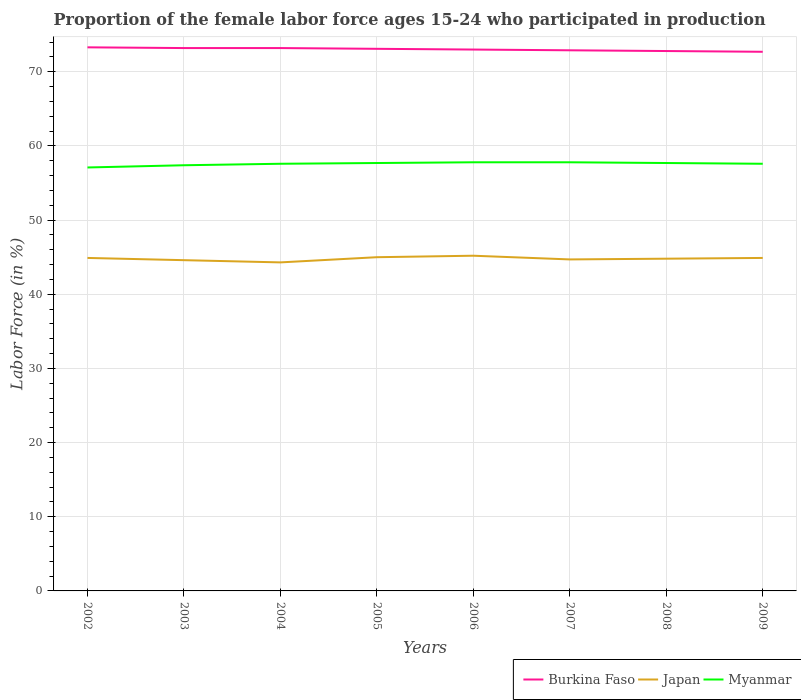How many different coloured lines are there?
Keep it short and to the point. 3. Across all years, what is the maximum proportion of the female labor force who participated in production in Myanmar?
Your response must be concise. 57.1. In which year was the proportion of the female labor force who participated in production in Japan maximum?
Give a very brief answer. 2004. What is the total proportion of the female labor force who participated in production in Japan in the graph?
Offer a terse response. -0.2. What is the difference between the highest and the second highest proportion of the female labor force who participated in production in Burkina Faso?
Offer a terse response. 0.6. What is the difference between the highest and the lowest proportion of the female labor force who participated in production in Burkina Faso?
Your response must be concise. 4. How many lines are there?
Offer a very short reply. 3. What is the difference between two consecutive major ticks on the Y-axis?
Make the answer very short. 10. Does the graph contain any zero values?
Offer a terse response. No. What is the title of the graph?
Your answer should be compact. Proportion of the female labor force ages 15-24 who participated in production. Does "Burkina Faso" appear as one of the legend labels in the graph?
Keep it short and to the point. Yes. What is the label or title of the Y-axis?
Your answer should be very brief. Labor Force (in %). What is the Labor Force (in %) of Burkina Faso in 2002?
Your answer should be very brief. 73.3. What is the Labor Force (in %) of Japan in 2002?
Your answer should be very brief. 44.9. What is the Labor Force (in %) of Myanmar in 2002?
Your answer should be very brief. 57.1. What is the Labor Force (in %) in Burkina Faso in 2003?
Keep it short and to the point. 73.2. What is the Labor Force (in %) in Japan in 2003?
Offer a very short reply. 44.6. What is the Labor Force (in %) in Myanmar in 2003?
Offer a very short reply. 57.4. What is the Labor Force (in %) of Burkina Faso in 2004?
Ensure brevity in your answer.  73.2. What is the Labor Force (in %) in Japan in 2004?
Provide a short and direct response. 44.3. What is the Labor Force (in %) of Myanmar in 2004?
Your answer should be compact. 57.6. What is the Labor Force (in %) in Burkina Faso in 2005?
Your response must be concise. 73.1. What is the Labor Force (in %) of Japan in 2005?
Keep it short and to the point. 45. What is the Labor Force (in %) of Myanmar in 2005?
Provide a short and direct response. 57.7. What is the Labor Force (in %) of Burkina Faso in 2006?
Provide a succinct answer. 73. What is the Labor Force (in %) of Japan in 2006?
Provide a succinct answer. 45.2. What is the Labor Force (in %) in Myanmar in 2006?
Provide a succinct answer. 57.8. What is the Labor Force (in %) in Burkina Faso in 2007?
Keep it short and to the point. 72.9. What is the Labor Force (in %) of Japan in 2007?
Your response must be concise. 44.7. What is the Labor Force (in %) in Myanmar in 2007?
Your response must be concise. 57.8. What is the Labor Force (in %) in Burkina Faso in 2008?
Your response must be concise. 72.8. What is the Labor Force (in %) of Japan in 2008?
Provide a succinct answer. 44.8. What is the Labor Force (in %) in Myanmar in 2008?
Give a very brief answer. 57.7. What is the Labor Force (in %) of Burkina Faso in 2009?
Your response must be concise. 72.7. What is the Labor Force (in %) of Japan in 2009?
Give a very brief answer. 44.9. What is the Labor Force (in %) of Myanmar in 2009?
Your answer should be compact. 57.6. Across all years, what is the maximum Labor Force (in %) of Burkina Faso?
Your response must be concise. 73.3. Across all years, what is the maximum Labor Force (in %) in Japan?
Your answer should be compact. 45.2. Across all years, what is the maximum Labor Force (in %) in Myanmar?
Your answer should be very brief. 57.8. Across all years, what is the minimum Labor Force (in %) in Burkina Faso?
Your answer should be very brief. 72.7. Across all years, what is the minimum Labor Force (in %) of Japan?
Your answer should be very brief. 44.3. Across all years, what is the minimum Labor Force (in %) of Myanmar?
Your answer should be compact. 57.1. What is the total Labor Force (in %) in Burkina Faso in the graph?
Provide a succinct answer. 584.2. What is the total Labor Force (in %) in Japan in the graph?
Keep it short and to the point. 358.4. What is the total Labor Force (in %) in Myanmar in the graph?
Make the answer very short. 460.7. What is the difference between the Labor Force (in %) of Burkina Faso in 2002 and that in 2003?
Ensure brevity in your answer.  0.1. What is the difference between the Labor Force (in %) of Burkina Faso in 2002 and that in 2004?
Your answer should be very brief. 0.1. What is the difference between the Labor Force (in %) in Japan in 2002 and that in 2005?
Give a very brief answer. -0.1. What is the difference between the Labor Force (in %) of Myanmar in 2002 and that in 2005?
Keep it short and to the point. -0.6. What is the difference between the Labor Force (in %) in Burkina Faso in 2002 and that in 2006?
Your answer should be very brief. 0.3. What is the difference between the Labor Force (in %) of Japan in 2002 and that in 2007?
Give a very brief answer. 0.2. What is the difference between the Labor Force (in %) in Myanmar in 2002 and that in 2007?
Offer a terse response. -0.7. What is the difference between the Labor Force (in %) of Burkina Faso in 2002 and that in 2008?
Offer a terse response. 0.5. What is the difference between the Labor Force (in %) in Myanmar in 2002 and that in 2009?
Give a very brief answer. -0.5. What is the difference between the Labor Force (in %) of Burkina Faso in 2003 and that in 2004?
Your response must be concise. 0. What is the difference between the Labor Force (in %) of Japan in 2003 and that in 2004?
Provide a succinct answer. 0.3. What is the difference between the Labor Force (in %) of Myanmar in 2003 and that in 2004?
Give a very brief answer. -0.2. What is the difference between the Labor Force (in %) of Burkina Faso in 2003 and that in 2005?
Your answer should be very brief. 0.1. What is the difference between the Labor Force (in %) of Japan in 2003 and that in 2005?
Make the answer very short. -0.4. What is the difference between the Labor Force (in %) in Myanmar in 2003 and that in 2005?
Ensure brevity in your answer.  -0.3. What is the difference between the Labor Force (in %) of Japan in 2003 and that in 2007?
Ensure brevity in your answer.  -0.1. What is the difference between the Labor Force (in %) of Myanmar in 2003 and that in 2009?
Make the answer very short. -0.2. What is the difference between the Labor Force (in %) in Japan in 2004 and that in 2005?
Your answer should be compact. -0.7. What is the difference between the Labor Force (in %) of Myanmar in 2004 and that in 2005?
Your response must be concise. -0.1. What is the difference between the Labor Force (in %) in Myanmar in 2004 and that in 2006?
Offer a very short reply. -0.2. What is the difference between the Labor Force (in %) in Burkina Faso in 2004 and that in 2008?
Ensure brevity in your answer.  0.4. What is the difference between the Labor Force (in %) in Japan in 2004 and that in 2008?
Provide a succinct answer. -0.5. What is the difference between the Labor Force (in %) of Myanmar in 2004 and that in 2008?
Ensure brevity in your answer.  -0.1. What is the difference between the Labor Force (in %) in Burkina Faso in 2004 and that in 2009?
Your answer should be compact. 0.5. What is the difference between the Labor Force (in %) of Japan in 2005 and that in 2006?
Your answer should be compact. -0.2. What is the difference between the Labor Force (in %) in Burkina Faso in 2005 and that in 2007?
Offer a terse response. 0.2. What is the difference between the Labor Force (in %) of Burkina Faso in 2005 and that in 2008?
Give a very brief answer. 0.3. What is the difference between the Labor Force (in %) in Japan in 2005 and that in 2008?
Provide a succinct answer. 0.2. What is the difference between the Labor Force (in %) in Japan in 2005 and that in 2009?
Your response must be concise. 0.1. What is the difference between the Labor Force (in %) in Burkina Faso in 2006 and that in 2007?
Your answer should be compact. 0.1. What is the difference between the Labor Force (in %) in Japan in 2006 and that in 2007?
Give a very brief answer. 0.5. What is the difference between the Labor Force (in %) of Myanmar in 2006 and that in 2007?
Make the answer very short. 0. What is the difference between the Labor Force (in %) of Burkina Faso in 2006 and that in 2008?
Ensure brevity in your answer.  0.2. What is the difference between the Labor Force (in %) of Japan in 2006 and that in 2008?
Your answer should be very brief. 0.4. What is the difference between the Labor Force (in %) in Myanmar in 2006 and that in 2009?
Your answer should be compact. 0.2. What is the difference between the Labor Force (in %) in Japan in 2007 and that in 2008?
Ensure brevity in your answer.  -0.1. What is the difference between the Labor Force (in %) of Myanmar in 2007 and that in 2008?
Offer a terse response. 0.1. What is the difference between the Labor Force (in %) of Japan in 2007 and that in 2009?
Ensure brevity in your answer.  -0.2. What is the difference between the Labor Force (in %) of Myanmar in 2007 and that in 2009?
Offer a terse response. 0.2. What is the difference between the Labor Force (in %) in Japan in 2008 and that in 2009?
Keep it short and to the point. -0.1. What is the difference between the Labor Force (in %) of Burkina Faso in 2002 and the Labor Force (in %) of Japan in 2003?
Offer a very short reply. 28.7. What is the difference between the Labor Force (in %) in Burkina Faso in 2002 and the Labor Force (in %) in Myanmar in 2003?
Provide a succinct answer. 15.9. What is the difference between the Labor Force (in %) in Burkina Faso in 2002 and the Labor Force (in %) in Japan in 2004?
Provide a succinct answer. 29. What is the difference between the Labor Force (in %) of Burkina Faso in 2002 and the Labor Force (in %) of Japan in 2005?
Provide a short and direct response. 28.3. What is the difference between the Labor Force (in %) of Japan in 2002 and the Labor Force (in %) of Myanmar in 2005?
Your answer should be compact. -12.8. What is the difference between the Labor Force (in %) of Burkina Faso in 2002 and the Labor Force (in %) of Japan in 2006?
Your answer should be very brief. 28.1. What is the difference between the Labor Force (in %) in Burkina Faso in 2002 and the Labor Force (in %) in Myanmar in 2006?
Your response must be concise. 15.5. What is the difference between the Labor Force (in %) of Japan in 2002 and the Labor Force (in %) of Myanmar in 2006?
Provide a succinct answer. -12.9. What is the difference between the Labor Force (in %) of Burkina Faso in 2002 and the Labor Force (in %) of Japan in 2007?
Offer a terse response. 28.6. What is the difference between the Labor Force (in %) of Burkina Faso in 2002 and the Labor Force (in %) of Myanmar in 2007?
Give a very brief answer. 15.5. What is the difference between the Labor Force (in %) of Japan in 2002 and the Labor Force (in %) of Myanmar in 2007?
Make the answer very short. -12.9. What is the difference between the Labor Force (in %) of Burkina Faso in 2002 and the Labor Force (in %) of Japan in 2008?
Ensure brevity in your answer.  28.5. What is the difference between the Labor Force (in %) of Burkina Faso in 2002 and the Labor Force (in %) of Myanmar in 2008?
Your response must be concise. 15.6. What is the difference between the Labor Force (in %) of Japan in 2002 and the Labor Force (in %) of Myanmar in 2008?
Your answer should be very brief. -12.8. What is the difference between the Labor Force (in %) of Burkina Faso in 2002 and the Labor Force (in %) of Japan in 2009?
Keep it short and to the point. 28.4. What is the difference between the Labor Force (in %) in Burkina Faso in 2002 and the Labor Force (in %) in Myanmar in 2009?
Provide a succinct answer. 15.7. What is the difference between the Labor Force (in %) in Japan in 2002 and the Labor Force (in %) in Myanmar in 2009?
Provide a succinct answer. -12.7. What is the difference between the Labor Force (in %) in Burkina Faso in 2003 and the Labor Force (in %) in Japan in 2004?
Your answer should be very brief. 28.9. What is the difference between the Labor Force (in %) of Burkina Faso in 2003 and the Labor Force (in %) of Japan in 2005?
Offer a terse response. 28.2. What is the difference between the Labor Force (in %) of Japan in 2003 and the Labor Force (in %) of Myanmar in 2005?
Give a very brief answer. -13.1. What is the difference between the Labor Force (in %) of Burkina Faso in 2003 and the Labor Force (in %) of Japan in 2006?
Make the answer very short. 28. What is the difference between the Labor Force (in %) of Burkina Faso in 2003 and the Labor Force (in %) of Japan in 2008?
Offer a very short reply. 28.4. What is the difference between the Labor Force (in %) of Burkina Faso in 2003 and the Labor Force (in %) of Myanmar in 2008?
Your answer should be very brief. 15.5. What is the difference between the Labor Force (in %) of Japan in 2003 and the Labor Force (in %) of Myanmar in 2008?
Your answer should be compact. -13.1. What is the difference between the Labor Force (in %) in Burkina Faso in 2003 and the Labor Force (in %) in Japan in 2009?
Your answer should be compact. 28.3. What is the difference between the Labor Force (in %) in Burkina Faso in 2003 and the Labor Force (in %) in Myanmar in 2009?
Ensure brevity in your answer.  15.6. What is the difference between the Labor Force (in %) of Burkina Faso in 2004 and the Labor Force (in %) of Japan in 2005?
Your answer should be very brief. 28.2. What is the difference between the Labor Force (in %) in Burkina Faso in 2004 and the Labor Force (in %) in Myanmar in 2005?
Your response must be concise. 15.5. What is the difference between the Labor Force (in %) in Japan in 2004 and the Labor Force (in %) in Myanmar in 2005?
Provide a succinct answer. -13.4. What is the difference between the Labor Force (in %) in Burkina Faso in 2004 and the Labor Force (in %) in Myanmar in 2007?
Provide a short and direct response. 15.4. What is the difference between the Labor Force (in %) of Burkina Faso in 2004 and the Labor Force (in %) of Japan in 2008?
Offer a terse response. 28.4. What is the difference between the Labor Force (in %) of Burkina Faso in 2004 and the Labor Force (in %) of Myanmar in 2008?
Your answer should be very brief. 15.5. What is the difference between the Labor Force (in %) in Japan in 2004 and the Labor Force (in %) in Myanmar in 2008?
Offer a terse response. -13.4. What is the difference between the Labor Force (in %) of Burkina Faso in 2004 and the Labor Force (in %) of Japan in 2009?
Your answer should be compact. 28.3. What is the difference between the Labor Force (in %) of Japan in 2004 and the Labor Force (in %) of Myanmar in 2009?
Provide a short and direct response. -13.3. What is the difference between the Labor Force (in %) in Burkina Faso in 2005 and the Labor Force (in %) in Japan in 2006?
Offer a very short reply. 27.9. What is the difference between the Labor Force (in %) in Burkina Faso in 2005 and the Labor Force (in %) in Japan in 2007?
Your answer should be compact. 28.4. What is the difference between the Labor Force (in %) in Burkina Faso in 2005 and the Labor Force (in %) in Japan in 2008?
Give a very brief answer. 28.3. What is the difference between the Labor Force (in %) of Burkina Faso in 2005 and the Labor Force (in %) of Myanmar in 2008?
Provide a succinct answer. 15.4. What is the difference between the Labor Force (in %) of Japan in 2005 and the Labor Force (in %) of Myanmar in 2008?
Your answer should be very brief. -12.7. What is the difference between the Labor Force (in %) in Burkina Faso in 2005 and the Labor Force (in %) in Japan in 2009?
Keep it short and to the point. 28.2. What is the difference between the Labor Force (in %) of Burkina Faso in 2005 and the Labor Force (in %) of Myanmar in 2009?
Ensure brevity in your answer.  15.5. What is the difference between the Labor Force (in %) in Japan in 2005 and the Labor Force (in %) in Myanmar in 2009?
Your response must be concise. -12.6. What is the difference between the Labor Force (in %) of Burkina Faso in 2006 and the Labor Force (in %) of Japan in 2007?
Your answer should be very brief. 28.3. What is the difference between the Labor Force (in %) of Burkina Faso in 2006 and the Labor Force (in %) of Myanmar in 2007?
Your answer should be very brief. 15.2. What is the difference between the Labor Force (in %) in Japan in 2006 and the Labor Force (in %) in Myanmar in 2007?
Provide a succinct answer. -12.6. What is the difference between the Labor Force (in %) in Burkina Faso in 2006 and the Labor Force (in %) in Japan in 2008?
Provide a succinct answer. 28.2. What is the difference between the Labor Force (in %) in Burkina Faso in 2006 and the Labor Force (in %) in Japan in 2009?
Your answer should be very brief. 28.1. What is the difference between the Labor Force (in %) in Burkina Faso in 2006 and the Labor Force (in %) in Myanmar in 2009?
Ensure brevity in your answer.  15.4. What is the difference between the Labor Force (in %) of Burkina Faso in 2007 and the Labor Force (in %) of Japan in 2008?
Make the answer very short. 28.1. What is the difference between the Labor Force (in %) in Burkina Faso in 2007 and the Labor Force (in %) in Japan in 2009?
Your response must be concise. 28. What is the difference between the Labor Force (in %) in Japan in 2007 and the Labor Force (in %) in Myanmar in 2009?
Give a very brief answer. -12.9. What is the difference between the Labor Force (in %) in Burkina Faso in 2008 and the Labor Force (in %) in Japan in 2009?
Offer a terse response. 27.9. What is the difference between the Labor Force (in %) of Burkina Faso in 2008 and the Labor Force (in %) of Myanmar in 2009?
Keep it short and to the point. 15.2. What is the difference between the Labor Force (in %) of Japan in 2008 and the Labor Force (in %) of Myanmar in 2009?
Ensure brevity in your answer.  -12.8. What is the average Labor Force (in %) of Burkina Faso per year?
Your answer should be compact. 73.03. What is the average Labor Force (in %) in Japan per year?
Make the answer very short. 44.8. What is the average Labor Force (in %) in Myanmar per year?
Give a very brief answer. 57.59. In the year 2002, what is the difference between the Labor Force (in %) of Burkina Faso and Labor Force (in %) of Japan?
Provide a short and direct response. 28.4. In the year 2003, what is the difference between the Labor Force (in %) in Burkina Faso and Labor Force (in %) in Japan?
Your answer should be very brief. 28.6. In the year 2003, what is the difference between the Labor Force (in %) in Burkina Faso and Labor Force (in %) in Myanmar?
Give a very brief answer. 15.8. In the year 2003, what is the difference between the Labor Force (in %) in Japan and Labor Force (in %) in Myanmar?
Your response must be concise. -12.8. In the year 2004, what is the difference between the Labor Force (in %) in Burkina Faso and Labor Force (in %) in Japan?
Provide a short and direct response. 28.9. In the year 2005, what is the difference between the Labor Force (in %) of Burkina Faso and Labor Force (in %) of Japan?
Make the answer very short. 28.1. In the year 2006, what is the difference between the Labor Force (in %) in Burkina Faso and Labor Force (in %) in Japan?
Provide a short and direct response. 27.8. In the year 2006, what is the difference between the Labor Force (in %) in Burkina Faso and Labor Force (in %) in Myanmar?
Make the answer very short. 15.2. In the year 2006, what is the difference between the Labor Force (in %) in Japan and Labor Force (in %) in Myanmar?
Provide a succinct answer. -12.6. In the year 2007, what is the difference between the Labor Force (in %) of Burkina Faso and Labor Force (in %) of Japan?
Provide a short and direct response. 28.2. In the year 2007, what is the difference between the Labor Force (in %) in Japan and Labor Force (in %) in Myanmar?
Provide a succinct answer. -13.1. In the year 2008, what is the difference between the Labor Force (in %) in Burkina Faso and Labor Force (in %) in Japan?
Offer a very short reply. 28. In the year 2008, what is the difference between the Labor Force (in %) of Japan and Labor Force (in %) of Myanmar?
Your response must be concise. -12.9. In the year 2009, what is the difference between the Labor Force (in %) in Burkina Faso and Labor Force (in %) in Japan?
Provide a succinct answer. 27.8. What is the ratio of the Labor Force (in %) of Burkina Faso in 2002 to that in 2003?
Offer a very short reply. 1. What is the ratio of the Labor Force (in %) of Japan in 2002 to that in 2003?
Give a very brief answer. 1.01. What is the ratio of the Labor Force (in %) in Myanmar in 2002 to that in 2003?
Keep it short and to the point. 0.99. What is the ratio of the Labor Force (in %) in Burkina Faso in 2002 to that in 2004?
Your answer should be compact. 1. What is the ratio of the Labor Force (in %) of Japan in 2002 to that in 2004?
Make the answer very short. 1.01. What is the ratio of the Labor Force (in %) in Japan in 2002 to that in 2005?
Your answer should be very brief. 1. What is the ratio of the Labor Force (in %) of Burkina Faso in 2002 to that in 2006?
Offer a terse response. 1. What is the ratio of the Labor Force (in %) in Myanmar in 2002 to that in 2006?
Your answer should be very brief. 0.99. What is the ratio of the Labor Force (in %) in Myanmar in 2002 to that in 2007?
Your answer should be compact. 0.99. What is the ratio of the Labor Force (in %) in Burkina Faso in 2002 to that in 2008?
Your answer should be compact. 1.01. What is the ratio of the Labor Force (in %) of Burkina Faso in 2002 to that in 2009?
Offer a very short reply. 1.01. What is the ratio of the Labor Force (in %) of Japan in 2003 to that in 2004?
Your answer should be very brief. 1.01. What is the ratio of the Labor Force (in %) of Myanmar in 2003 to that in 2004?
Your answer should be very brief. 1. What is the ratio of the Labor Force (in %) of Japan in 2003 to that in 2005?
Your response must be concise. 0.99. What is the ratio of the Labor Force (in %) of Japan in 2003 to that in 2006?
Ensure brevity in your answer.  0.99. What is the ratio of the Labor Force (in %) in Myanmar in 2003 to that in 2006?
Keep it short and to the point. 0.99. What is the ratio of the Labor Force (in %) in Japan in 2003 to that in 2007?
Make the answer very short. 1. What is the ratio of the Labor Force (in %) of Myanmar in 2003 to that in 2007?
Your answer should be very brief. 0.99. What is the ratio of the Labor Force (in %) in Burkina Faso in 2003 to that in 2008?
Your answer should be compact. 1.01. What is the ratio of the Labor Force (in %) in Myanmar in 2003 to that in 2009?
Your answer should be very brief. 1. What is the ratio of the Labor Force (in %) of Burkina Faso in 2004 to that in 2005?
Provide a short and direct response. 1. What is the ratio of the Labor Force (in %) of Japan in 2004 to that in 2005?
Your response must be concise. 0.98. What is the ratio of the Labor Force (in %) in Japan in 2004 to that in 2006?
Make the answer very short. 0.98. What is the ratio of the Labor Force (in %) in Myanmar in 2004 to that in 2006?
Give a very brief answer. 1. What is the ratio of the Labor Force (in %) of Burkina Faso in 2004 to that in 2007?
Your answer should be compact. 1. What is the ratio of the Labor Force (in %) of Myanmar in 2004 to that in 2007?
Ensure brevity in your answer.  1. What is the ratio of the Labor Force (in %) of Japan in 2004 to that in 2008?
Ensure brevity in your answer.  0.99. What is the ratio of the Labor Force (in %) in Burkina Faso in 2004 to that in 2009?
Provide a succinct answer. 1.01. What is the ratio of the Labor Force (in %) of Japan in 2004 to that in 2009?
Provide a succinct answer. 0.99. What is the ratio of the Labor Force (in %) of Myanmar in 2004 to that in 2009?
Provide a short and direct response. 1. What is the ratio of the Labor Force (in %) in Myanmar in 2005 to that in 2006?
Give a very brief answer. 1. What is the ratio of the Labor Force (in %) in Myanmar in 2005 to that in 2007?
Your response must be concise. 1. What is the ratio of the Labor Force (in %) of Burkina Faso in 2005 to that in 2008?
Provide a short and direct response. 1. What is the ratio of the Labor Force (in %) in Myanmar in 2005 to that in 2008?
Give a very brief answer. 1. What is the ratio of the Labor Force (in %) in Burkina Faso in 2005 to that in 2009?
Ensure brevity in your answer.  1.01. What is the ratio of the Labor Force (in %) in Japan in 2005 to that in 2009?
Your answer should be very brief. 1. What is the ratio of the Labor Force (in %) in Burkina Faso in 2006 to that in 2007?
Keep it short and to the point. 1. What is the ratio of the Labor Force (in %) in Japan in 2006 to that in 2007?
Your answer should be very brief. 1.01. What is the ratio of the Labor Force (in %) of Japan in 2006 to that in 2008?
Offer a very short reply. 1.01. What is the ratio of the Labor Force (in %) in Myanmar in 2006 to that in 2008?
Provide a short and direct response. 1. What is the ratio of the Labor Force (in %) of Burkina Faso in 2006 to that in 2009?
Offer a terse response. 1. What is the ratio of the Labor Force (in %) of Myanmar in 2006 to that in 2009?
Offer a terse response. 1. What is the ratio of the Labor Force (in %) in Japan in 2007 to that in 2008?
Your answer should be compact. 1. What is the ratio of the Labor Force (in %) in Myanmar in 2007 to that in 2008?
Offer a terse response. 1. What is the ratio of the Labor Force (in %) of Burkina Faso in 2007 to that in 2009?
Provide a short and direct response. 1. What is the ratio of the Labor Force (in %) in Myanmar in 2007 to that in 2009?
Ensure brevity in your answer.  1. What is the ratio of the Labor Force (in %) of Burkina Faso in 2008 to that in 2009?
Your response must be concise. 1. What is the difference between the highest and the second highest Labor Force (in %) of Burkina Faso?
Provide a short and direct response. 0.1. What is the difference between the highest and the lowest Labor Force (in %) of Japan?
Offer a very short reply. 0.9. 